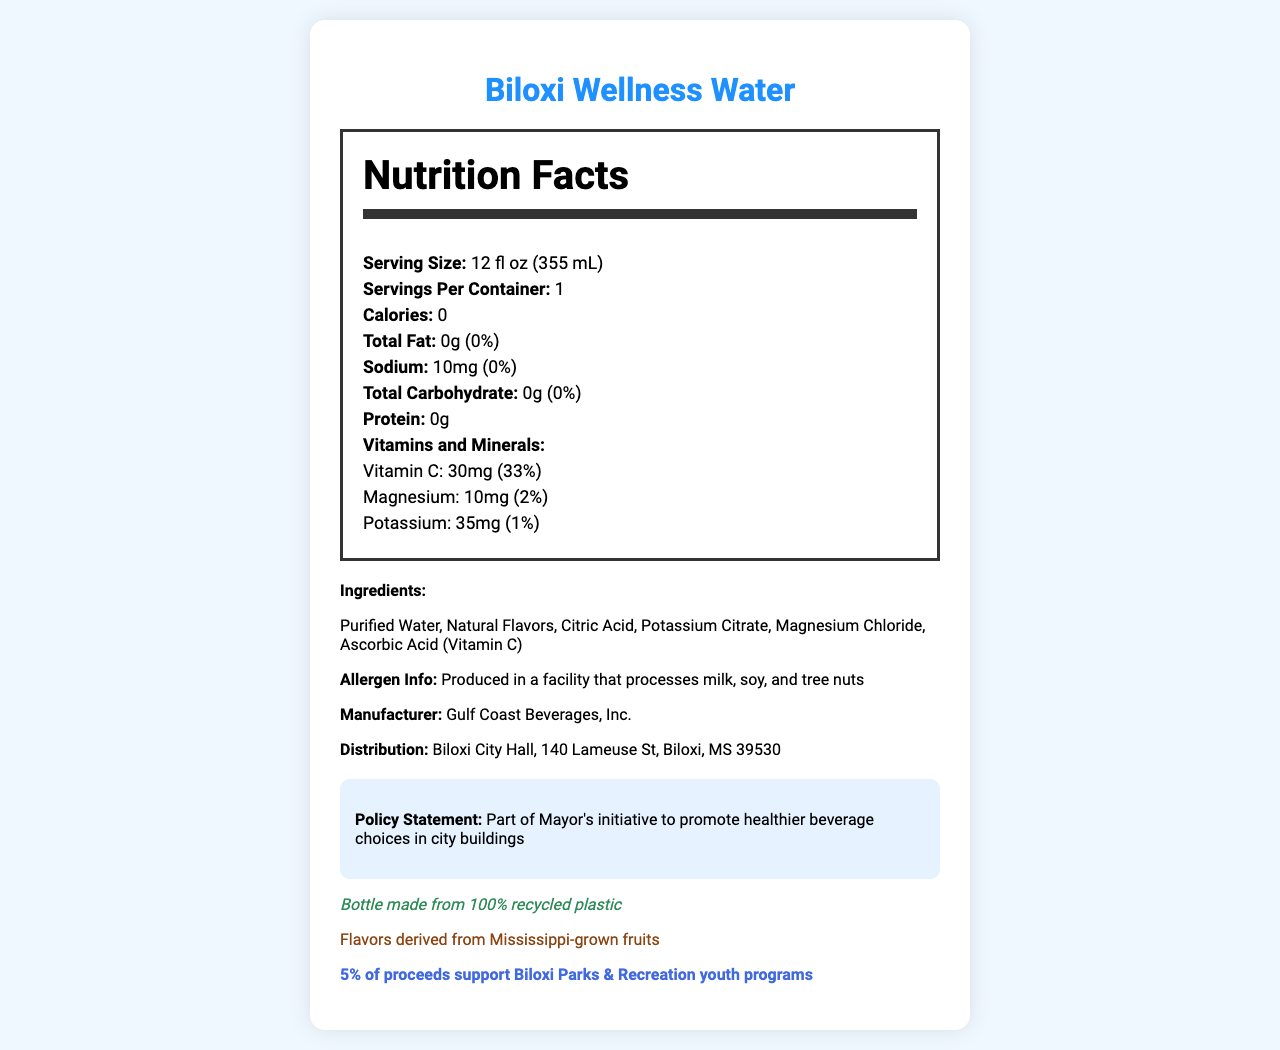what is the serving size of Biloxi Wellness Water? The serving size is specified as "12 fl oz (355 mL)" in the document.
Answer: 12 fl oz (355 mL) how many calories are in a serving of Biloxi Wellness Water? The document indicates that the beverage has 0 calories per serving.
Answer: 0 calories what percentage of the daily value of Vitamin C does Biloxi Wellness Water provide? The document shows that the Vitamin C content is 30mg, which is 33% of the daily value.
Answer: 33% what is the amount of sodium in this beverage? The sodium content is listed as "10mg" in the document.
Answer: 10mg what ingredients are used in this beverage? The ingredients listed in the document include Purified Water, Natural Flavors, Citric Acid, Potassium Citrate, Magnesium Chloride, and Ascorbic Acid (Vitamin C).
Answer: Purified Water, Natural Flavors, Citric Acid, Potassium Citrate, Magnesium Chloride, Ascorbic Acid (Vitamin C) which vitamin is present at 33% of the daily value? The document indicates that Vitamin C is present at 33% of the daily value.
Answer: Vitamin C who is the manufacturer of Biloxi Wellness Water? The manufacturer is specified as Gulf Coast Beverages, Inc.
Answer: Gulf Coast Beverages, Inc. what is the location for the distribution of this beverage? The distribution location provided is Biloxi City Hall, 140 Lameuse St, Biloxi, MS 39530.
Answer: Biloxi City Hall, 140 Lameuse St, Biloxi, MS 39530 Which of the following vitamins and minerals is NOT included in Biloxi Wellness Water? A. Vitamin B12 B. Vitamin C C. Magnesium The document lists Vitamin C, Magnesium, and Potassium but does not mention Vitamin B12.
Answer: A Which statement about the packaging of Biloxi Wellness Water is true? A. It is made from 50% recycled plastic B. It is made from 100% recycled plastic C. It is made from non-recycled plastic The document states that the bottle is made from 100% recycled plastic.
Answer: B Is Biloxi Wellness Water suitable for people with nut allergies? Although the beverage itself may not contain nuts, it is produced in a facility that processes milk, soy, and tree nuts, according to the allergen info.
Answer: No Summarize the main goal of this document. The document details multiple aspects of the product, including its nutritional content, production, and community benefits, tying it into a broader health initiative.
Answer: The document describes the nutrition facts, ingredients, manufacturer details, and health and environmental benefits of Biloxi Wellness Water, a sugar-free beverage. It is part of the mayor's initiative to promote healthier beverage choices in city buildings and supports local sourcing and community programs. what is the daily value percentage of potassium in the beverage? The document indicates that the potassium content is 35mg, which is 1% of the daily value.
Answer: 1% which flavor source is used in Biloxi Wellness Water? The document states that the flavors are derived from Mississippi-grown fruits.
Answer: Natural Flavors derived from Mississippi-grown fruits what is the main purpose of the policy statement? The document mentions that the policy is part of the mayor's initiative to encourage healthier beverage choices in city buildings.
Answer: To promote healthier beverage choices in city buildings how many servings are there in one container of Biloxi Wellness Water? The document states that there is 1 serving per container.
Answer: 1 serving per container Does the beverage contain any artificial flavors? The document lists Natural Flavors as an ingredient but does not mention any artificial flavors.
Answer: No Who can be contacted for more information about the policy governing Biloxi Wellness Water? The document does not provide contact information for inquiries related to the policy.
Answer: Cannot be determined 